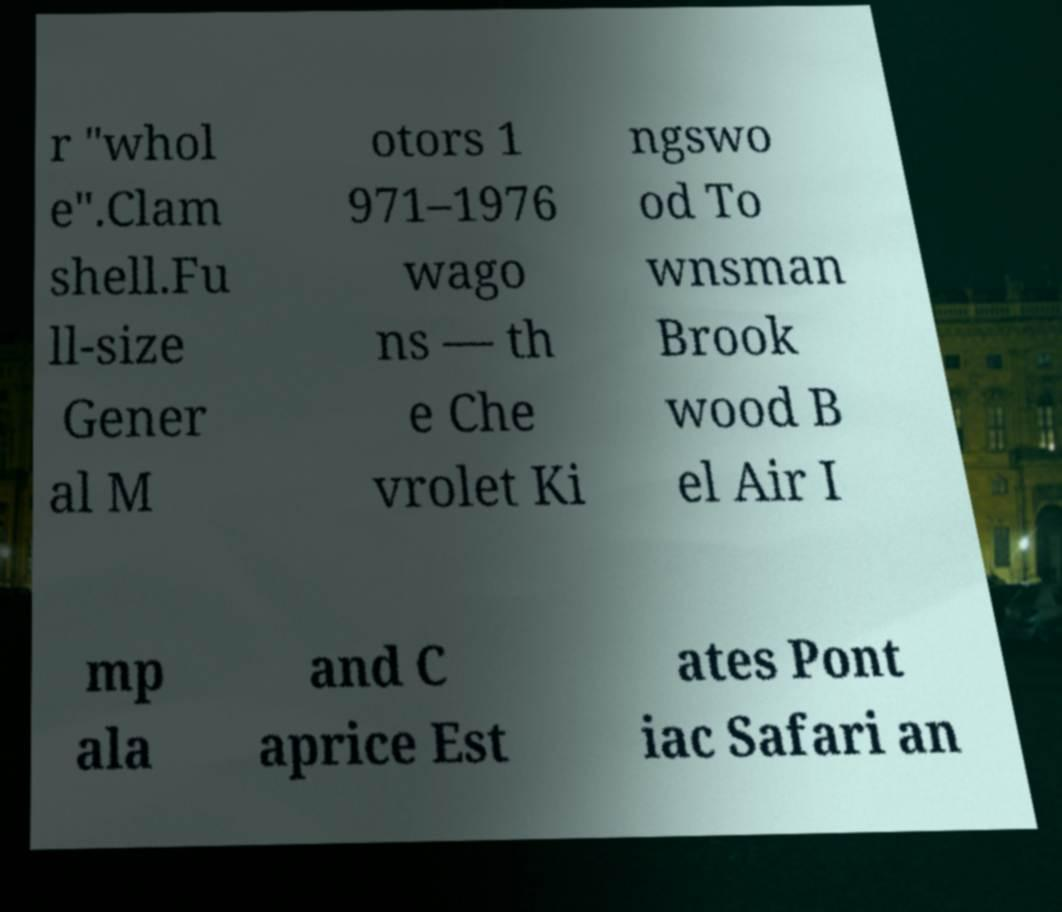I need the written content from this picture converted into text. Can you do that? r "whol e".Clam shell.Fu ll-size Gener al M otors 1 971–1976 wago ns — th e Che vrolet Ki ngswo od To wnsman Brook wood B el Air I mp ala and C aprice Est ates Pont iac Safari an 